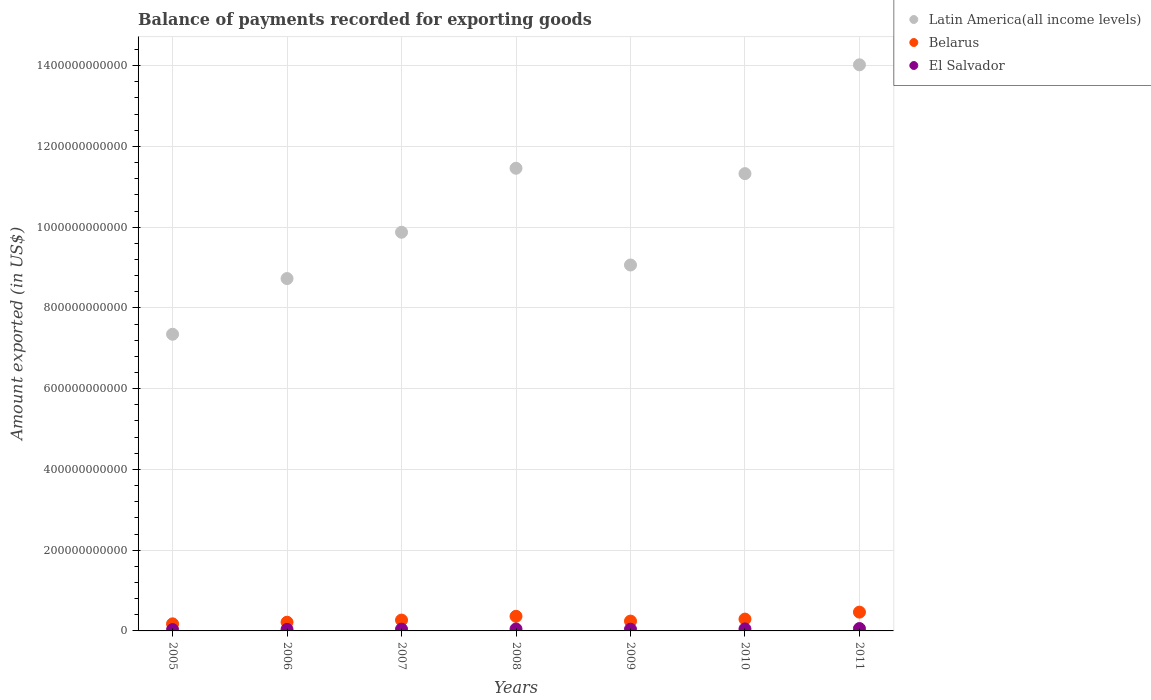How many different coloured dotlines are there?
Provide a succinct answer. 3. Is the number of dotlines equal to the number of legend labels?
Your response must be concise. Yes. What is the amount exported in Latin America(all income levels) in 2008?
Ensure brevity in your answer.  1.15e+12. Across all years, what is the maximum amount exported in El Salvador?
Your response must be concise. 5.88e+09. Across all years, what is the minimum amount exported in Latin America(all income levels)?
Keep it short and to the point. 7.35e+11. In which year was the amount exported in Belarus maximum?
Your answer should be compact. 2011. In which year was the amount exported in Belarus minimum?
Your response must be concise. 2005. What is the total amount exported in Belarus in the graph?
Provide a succinct answer. 2.02e+11. What is the difference between the amount exported in Latin America(all income levels) in 2009 and that in 2010?
Provide a succinct answer. -2.26e+11. What is the difference between the amount exported in Latin America(all income levels) in 2005 and the amount exported in El Salvador in 2008?
Provide a succinct answer. 7.30e+11. What is the average amount exported in Latin America(all income levels) per year?
Provide a short and direct response. 1.03e+12. In the year 2006, what is the difference between the amount exported in Belarus and amount exported in Latin America(all income levels)?
Your answer should be very brief. -8.51e+11. What is the ratio of the amount exported in El Salvador in 2007 to that in 2011?
Ensure brevity in your answer.  0.74. What is the difference between the highest and the second highest amount exported in Belarus?
Offer a terse response. 1.03e+1. What is the difference between the highest and the lowest amount exported in El Salvador?
Offer a terse response. 2.54e+09. In how many years, is the amount exported in Belarus greater than the average amount exported in Belarus taken over all years?
Ensure brevity in your answer.  3. Is the sum of the amount exported in Latin America(all income levels) in 2008 and 2009 greater than the maximum amount exported in El Salvador across all years?
Your response must be concise. Yes. Does the amount exported in Belarus monotonically increase over the years?
Offer a very short reply. No. What is the difference between two consecutive major ticks on the Y-axis?
Your answer should be compact. 2.00e+11. Are the values on the major ticks of Y-axis written in scientific E-notation?
Your answer should be very brief. No. Does the graph contain any zero values?
Offer a terse response. No. Does the graph contain grids?
Offer a very short reply. Yes. How many legend labels are there?
Ensure brevity in your answer.  3. What is the title of the graph?
Your answer should be compact. Balance of payments recorded for exporting goods. What is the label or title of the X-axis?
Offer a terse response. Years. What is the label or title of the Y-axis?
Provide a succinct answer. Amount exported (in US$). What is the Amount exported (in US$) in Latin America(all income levels) in 2005?
Offer a very short reply. 7.35e+11. What is the Amount exported (in US$) of Belarus in 2005?
Offer a very short reply. 1.75e+1. What is the Amount exported (in US$) in El Salvador in 2005?
Provide a succinct answer. 3.34e+09. What is the Amount exported (in US$) of Latin America(all income levels) in 2006?
Offer a terse response. 8.73e+11. What is the Amount exported (in US$) of Belarus in 2006?
Your answer should be very brief. 2.16e+1. What is the Amount exported (in US$) in El Salvador in 2006?
Keep it short and to the point. 3.77e+09. What is the Amount exported (in US$) in Latin America(all income levels) in 2007?
Make the answer very short. 9.87e+11. What is the Amount exported (in US$) in Belarus in 2007?
Your answer should be compact. 2.69e+1. What is the Amount exported (in US$) in El Salvador in 2007?
Your answer should be compact. 4.35e+09. What is the Amount exported (in US$) in Latin America(all income levels) in 2008?
Keep it short and to the point. 1.15e+12. What is the Amount exported (in US$) in Belarus in 2008?
Your response must be concise. 3.62e+1. What is the Amount exported (in US$) of El Salvador in 2008?
Your answer should be compact. 4.81e+09. What is the Amount exported (in US$) of Latin America(all income levels) in 2009?
Keep it short and to the point. 9.06e+11. What is the Amount exported (in US$) of Belarus in 2009?
Keep it short and to the point. 2.43e+1. What is the Amount exported (in US$) in El Salvador in 2009?
Provide a succinct answer. 4.22e+09. What is the Amount exported (in US$) of Latin America(all income levels) in 2010?
Your answer should be very brief. 1.13e+12. What is the Amount exported (in US$) of Belarus in 2010?
Your answer should be compact. 2.93e+1. What is the Amount exported (in US$) in El Salvador in 2010?
Your response must be concise. 4.97e+09. What is the Amount exported (in US$) in Latin America(all income levels) in 2011?
Provide a succinct answer. 1.40e+12. What is the Amount exported (in US$) in Belarus in 2011?
Ensure brevity in your answer.  4.65e+1. What is the Amount exported (in US$) of El Salvador in 2011?
Your response must be concise. 5.88e+09. Across all years, what is the maximum Amount exported (in US$) of Latin America(all income levels)?
Your response must be concise. 1.40e+12. Across all years, what is the maximum Amount exported (in US$) of Belarus?
Give a very brief answer. 4.65e+1. Across all years, what is the maximum Amount exported (in US$) in El Salvador?
Your response must be concise. 5.88e+09. Across all years, what is the minimum Amount exported (in US$) in Latin America(all income levels)?
Ensure brevity in your answer.  7.35e+11. Across all years, what is the minimum Amount exported (in US$) in Belarus?
Provide a short and direct response. 1.75e+1. Across all years, what is the minimum Amount exported (in US$) of El Salvador?
Offer a very short reply. 3.34e+09. What is the total Amount exported (in US$) of Latin America(all income levels) in the graph?
Your answer should be compact. 7.18e+12. What is the total Amount exported (in US$) of Belarus in the graph?
Your answer should be very brief. 2.02e+11. What is the total Amount exported (in US$) of El Salvador in the graph?
Offer a terse response. 3.13e+1. What is the difference between the Amount exported (in US$) of Latin America(all income levels) in 2005 and that in 2006?
Your answer should be very brief. -1.38e+11. What is the difference between the Amount exported (in US$) in Belarus in 2005 and that in 2006?
Provide a succinct answer. -4.03e+09. What is the difference between the Amount exported (in US$) of El Salvador in 2005 and that in 2006?
Offer a very short reply. -4.29e+08. What is the difference between the Amount exported (in US$) in Latin America(all income levels) in 2005 and that in 2007?
Ensure brevity in your answer.  -2.53e+11. What is the difference between the Amount exported (in US$) in Belarus in 2005 and that in 2007?
Offer a very short reply. -9.32e+09. What is the difference between the Amount exported (in US$) in El Salvador in 2005 and that in 2007?
Your answer should be very brief. -1.01e+09. What is the difference between the Amount exported (in US$) of Latin America(all income levels) in 2005 and that in 2008?
Give a very brief answer. -4.11e+11. What is the difference between the Amount exported (in US$) in Belarus in 2005 and that in 2008?
Give a very brief answer. -1.87e+1. What is the difference between the Amount exported (in US$) in El Salvador in 2005 and that in 2008?
Offer a terse response. -1.47e+09. What is the difference between the Amount exported (in US$) in Latin America(all income levels) in 2005 and that in 2009?
Keep it short and to the point. -1.72e+11. What is the difference between the Amount exported (in US$) in Belarus in 2005 and that in 2009?
Your answer should be very brief. -6.77e+09. What is the difference between the Amount exported (in US$) in El Salvador in 2005 and that in 2009?
Offer a terse response. -8.74e+08. What is the difference between the Amount exported (in US$) in Latin America(all income levels) in 2005 and that in 2010?
Your answer should be very brief. -3.98e+11. What is the difference between the Amount exported (in US$) of Belarus in 2005 and that in 2010?
Ensure brevity in your answer.  -1.18e+1. What is the difference between the Amount exported (in US$) of El Salvador in 2005 and that in 2010?
Your response must be concise. -1.63e+09. What is the difference between the Amount exported (in US$) of Latin America(all income levels) in 2005 and that in 2011?
Provide a short and direct response. -6.67e+11. What is the difference between the Amount exported (in US$) of Belarus in 2005 and that in 2011?
Make the answer very short. -2.90e+1. What is the difference between the Amount exported (in US$) of El Salvador in 2005 and that in 2011?
Your response must be concise. -2.54e+09. What is the difference between the Amount exported (in US$) in Latin America(all income levels) in 2006 and that in 2007?
Offer a very short reply. -1.15e+11. What is the difference between the Amount exported (in US$) in Belarus in 2006 and that in 2007?
Provide a short and direct response. -5.28e+09. What is the difference between the Amount exported (in US$) of El Salvador in 2006 and that in 2007?
Provide a succinct answer. -5.79e+08. What is the difference between the Amount exported (in US$) in Latin America(all income levels) in 2006 and that in 2008?
Provide a short and direct response. -2.73e+11. What is the difference between the Amount exported (in US$) in Belarus in 2006 and that in 2008?
Offer a very short reply. -1.46e+1. What is the difference between the Amount exported (in US$) of El Salvador in 2006 and that in 2008?
Keep it short and to the point. -1.04e+09. What is the difference between the Amount exported (in US$) in Latin America(all income levels) in 2006 and that in 2009?
Your answer should be very brief. -3.36e+1. What is the difference between the Amount exported (in US$) of Belarus in 2006 and that in 2009?
Offer a terse response. -2.74e+09. What is the difference between the Amount exported (in US$) of El Salvador in 2006 and that in 2009?
Your answer should be very brief. -4.45e+08. What is the difference between the Amount exported (in US$) of Latin America(all income levels) in 2006 and that in 2010?
Give a very brief answer. -2.60e+11. What is the difference between the Amount exported (in US$) in Belarus in 2006 and that in 2010?
Offer a very short reply. -7.73e+09. What is the difference between the Amount exported (in US$) of El Salvador in 2006 and that in 2010?
Give a very brief answer. -1.20e+09. What is the difference between the Amount exported (in US$) in Latin America(all income levels) in 2006 and that in 2011?
Give a very brief answer. -5.29e+11. What is the difference between the Amount exported (in US$) of Belarus in 2006 and that in 2011?
Ensure brevity in your answer.  -2.50e+1. What is the difference between the Amount exported (in US$) in El Salvador in 2006 and that in 2011?
Your response must be concise. -2.11e+09. What is the difference between the Amount exported (in US$) of Latin America(all income levels) in 2007 and that in 2008?
Provide a succinct answer. -1.58e+11. What is the difference between the Amount exported (in US$) of Belarus in 2007 and that in 2008?
Give a very brief answer. -9.37e+09. What is the difference between the Amount exported (in US$) of El Salvador in 2007 and that in 2008?
Ensure brevity in your answer.  -4.60e+08. What is the difference between the Amount exported (in US$) in Latin America(all income levels) in 2007 and that in 2009?
Ensure brevity in your answer.  8.11e+1. What is the difference between the Amount exported (in US$) in Belarus in 2007 and that in 2009?
Provide a succinct answer. 2.54e+09. What is the difference between the Amount exported (in US$) of El Salvador in 2007 and that in 2009?
Provide a succinct answer. 1.34e+08. What is the difference between the Amount exported (in US$) in Latin America(all income levels) in 2007 and that in 2010?
Provide a short and direct response. -1.45e+11. What is the difference between the Amount exported (in US$) of Belarus in 2007 and that in 2010?
Your response must be concise. -2.45e+09. What is the difference between the Amount exported (in US$) in El Salvador in 2007 and that in 2010?
Give a very brief answer. -6.22e+08. What is the difference between the Amount exported (in US$) of Latin America(all income levels) in 2007 and that in 2011?
Give a very brief answer. -4.15e+11. What is the difference between the Amount exported (in US$) of Belarus in 2007 and that in 2011?
Offer a very short reply. -1.97e+1. What is the difference between the Amount exported (in US$) in El Salvador in 2007 and that in 2011?
Provide a succinct answer. -1.53e+09. What is the difference between the Amount exported (in US$) in Latin America(all income levels) in 2008 and that in 2009?
Give a very brief answer. 2.40e+11. What is the difference between the Amount exported (in US$) in Belarus in 2008 and that in 2009?
Offer a terse response. 1.19e+1. What is the difference between the Amount exported (in US$) in El Salvador in 2008 and that in 2009?
Ensure brevity in your answer.  5.94e+08. What is the difference between the Amount exported (in US$) of Latin America(all income levels) in 2008 and that in 2010?
Your answer should be compact. 1.33e+1. What is the difference between the Amount exported (in US$) of Belarus in 2008 and that in 2010?
Offer a very short reply. 6.92e+09. What is the difference between the Amount exported (in US$) of El Salvador in 2008 and that in 2010?
Provide a short and direct response. -1.61e+08. What is the difference between the Amount exported (in US$) in Latin America(all income levels) in 2008 and that in 2011?
Offer a very short reply. -2.56e+11. What is the difference between the Amount exported (in US$) in Belarus in 2008 and that in 2011?
Provide a succinct answer. -1.03e+1. What is the difference between the Amount exported (in US$) in El Salvador in 2008 and that in 2011?
Make the answer very short. -1.07e+09. What is the difference between the Amount exported (in US$) of Latin America(all income levels) in 2009 and that in 2010?
Make the answer very short. -2.26e+11. What is the difference between the Amount exported (in US$) in Belarus in 2009 and that in 2010?
Provide a succinct answer. -4.99e+09. What is the difference between the Amount exported (in US$) in El Salvador in 2009 and that in 2010?
Give a very brief answer. -7.55e+08. What is the difference between the Amount exported (in US$) in Latin America(all income levels) in 2009 and that in 2011?
Your response must be concise. -4.96e+11. What is the difference between the Amount exported (in US$) in Belarus in 2009 and that in 2011?
Your answer should be very brief. -2.22e+1. What is the difference between the Amount exported (in US$) of El Salvador in 2009 and that in 2011?
Ensure brevity in your answer.  -1.66e+09. What is the difference between the Amount exported (in US$) of Latin America(all income levels) in 2010 and that in 2011?
Give a very brief answer. -2.70e+11. What is the difference between the Amount exported (in US$) of Belarus in 2010 and that in 2011?
Your response must be concise. -1.72e+1. What is the difference between the Amount exported (in US$) in El Salvador in 2010 and that in 2011?
Give a very brief answer. -9.07e+08. What is the difference between the Amount exported (in US$) in Latin America(all income levels) in 2005 and the Amount exported (in US$) in Belarus in 2006?
Give a very brief answer. 7.13e+11. What is the difference between the Amount exported (in US$) of Latin America(all income levels) in 2005 and the Amount exported (in US$) of El Salvador in 2006?
Your answer should be very brief. 7.31e+11. What is the difference between the Amount exported (in US$) of Belarus in 2005 and the Amount exported (in US$) of El Salvador in 2006?
Your answer should be very brief. 1.38e+1. What is the difference between the Amount exported (in US$) in Latin America(all income levels) in 2005 and the Amount exported (in US$) in Belarus in 2007?
Offer a terse response. 7.08e+11. What is the difference between the Amount exported (in US$) in Latin America(all income levels) in 2005 and the Amount exported (in US$) in El Salvador in 2007?
Give a very brief answer. 7.30e+11. What is the difference between the Amount exported (in US$) in Belarus in 2005 and the Amount exported (in US$) in El Salvador in 2007?
Your answer should be compact. 1.32e+1. What is the difference between the Amount exported (in US$) of Latin America(all income levels) in 2005 and the Amount exported (in US$) of Belarus in 2008?
Offer a terse response. 6.99e+11. What is the difference between the Amount exported (in US$) in Latin America(all income levels) in 2005 and the Amount exported (in US$) in El Salvador in 2008?
Make the answer very short. 7.30e+11. What is the difference between the Amount exported (in US$) in Belarus in 2005 and the Amount exported (in US$) in El Salvador in 2008?
Provide a short and direct response. 1.27e+1. What is the difference between the Amount exported (in US$) of Latin America(all income levels) in 2005 and the Amount exported (in US$) of Belarus in 2009?
Provide a short and direct response. 7.11e+11. What is the difference between the Amount exported (in US$) of Latin America(all income levels) in 2005 and the Amount exported (in US$) of El Salvador in 2009?
Provide a succinct answer. 7.31e+11. What is the difference between the Amount exported (in US$) of Belarus in 2005 and the Amount exported (in US$) of El Salvador in 2009?
Provide a succinct answer. 1.33e+1. What is the difference between the Amount exported (in US$) of Latin America(all income levels) in 2005 and the Amount exported (in US$) of Belarus in 2010?
Offer a terse response. 7.06e+11. What is the difference between the Amount exported (in US$) in Latin America(all income levels) in 2005 and the Amount exported (in US$) in El Salvador in 2010?
Your response must be concise. 7.30e+11. What is the difference between the Amount exported (in US$) in Belarus in 2005 and the Amount exported (in US$) in El Salvador in 2010?
Ensure brevity in your answer.  1.26e+1. What is the difference between the Amount exported (in US$) of Latin America(all income levels) in 2005 and the Amount exported (in US$) of Belarus in 2011?
Your response must be concise. 6.88e+11. What is the difference between the Amount exported (in US$) of Latin America(all income levels) in 2005 and the Amount exported (in US$) of El Salvador in 2011?
Your answer should be compact. 7.29e+11. What is the difference between the Amount exported (in US$) in Belarus in 2005 and the Amount exported (in US$) in El Salvador in 2011?
Provide a succinct answer. 1.17e+1. What is the difference between the Amount exported (in US$) in Latin America(all income levels) in 2006 and the Amount exported (in US$) in Belarus in 2007?
Your response must be concise. 8.46e+11. What is the difference between the Amount exported (in US$) of Latin America(all income levels) in 2006 and the Amount exported (in US$) of El Salvador in 2007?
Make the answer very short. 8.68e+11. What is the difference between the Amount exported (in US$) in Belarus in 2006 and the Amount exported (in US$) in El Salvador in 2007?
Your answer should be compact. 1.72e+1. What is the difference between the Amount exported (in US$) in Latin America(all income levels) in 2006 and the Amount exported (in US$) in Belarus in 2008?
Your answer should be compact. 8.37e+11. What is the difference between the Amount exported (in US$) of Latin America(all income levels) in 2006 and the Amount exported (in US$) of El Salvador in 2008?
Give a very brief answer. 8.68e+11. What is the difference between the Amount exported (in US$) in Belarus in 2006 and the Amount exported (in US$) in El Salvador in 2008?
Give a very brief answer. 1.68e+1. What is the difference between the Amount exported (in US$) in Latin America(all income levels) in 2006 and the Amount exported (in US$) in Belarus in 2009?
Offer a very short reply. 8.48e+11. What is the difference between the Amount exported (in US$) in Latin America(all income levels) in 2006 and the Amount exported (in US$) in El Salvador in 2009?
Your answer should be very brief. 8.69e+11. What is the difference between the Amount exported (in US$) of Belarus in 2006 and the Amount exported (in US$) of El Salvador in 2009?
Offer a very short reply. 1.74e+1. What is the difference between the Amount exported (in US$) of Latin America(all income levels) in 2006 and the Amount exported (in US$) of Belarus in 2010?
Make the answer very short. 8.43e+11. What is the difference between the Amount exported (in US$) of Latin America(all income levels) in 2006 and the Amount exported (in US$) of El Salvador in 2010?
Offer a terse response. 8.68e+11. What is the difference between the Amount exported (in US$) in Belarus in 2006 and the Amount exported (in US$) in El Salvador in 2010?
Keep it short and to the point. 1.66e+1. What is the difference between the Amount exported (in US$) of Latin America(all income levels) in 2006 and the Amount exported (in US$) of Belarus in 2011?
Ensure brevity in your answer.  8.26e+11. What is the difference between the Amount exported (in US$) of Latin America(all income levels) in 2006 and the Amount exported (in US$) of El Salvador in 2011?
Provide a short and direct response. 8.67e+11. What is the difference between the Amount exported (in US$) of Belarus in 2006 and the Amount exported (in US$) of El Salvador in 2011?
Make the answer very short. 1.57e+1. What is the difference between the Amount exported (in US$) in Latin America(all income levels) in 2007 and the Amount exported (in US$) in Belarus in 2008?
Offer a terse response. 9.51e+11. What is the difference between the Amount exported (in US$) in Latin America(all income levels) in 2007 and the Amount exported (in US$) in El Salvador in 2008?
Offer a terse response. 9.83e+11. What is the difference between the Amount exported (in US$) of Belarus in 2007 and the Amount exported (in US$) of El Salvador in 2008?
Give a very brief answer. 2.20e+1. What is the difference between the Amount exported (in US$) in Latin America(all income levels) in 2007 and the Amount exported (in US$) in Belarus in 2009?
Keep it short and to the point. 9.63e+11. What is the difference between the Amount exported (in US$) in Latin America(all income levels) in 2007 and the Amount exported (in US$) in El Salvador in 2009?
Your answer should be very brief. 9.83e+11. What is the difference between the Amount exported (in US$) in Belarus in 2007 and the Amount exported (in US$) in El Salvador in 2009?
Provide a short and direct response. 2.26e+1. What is the difference between the Amount exported (in US$) of Latin America(all income levels) in 2007 and the Amount exported (in US$) of Belarus in 2010?
Make the answer very short. 9.58e+11. What is the difference between the Amount exported (in US$) of Latin America(all income levels) in 2007 and the Amount exported (in US$) of El Salvador in 2010?
Give a very brief answer. 9.83e+11. What is the difference between the Amount exported (in US$) in Belarus in 2007 and the Amount exported (in US$) in El Salvador in 2010?
Make the answer very short. 2.19e+1. What is the difference between the Amount exported (in US$) of Latin America(all income levels) in 2007 and the Amount exported (in US$) of Belarus in 2011?
Provide a succinct answer. 9.41e+11. What is the difference between the Amount exported (in US$) in Latin America(all income levels) in 2007 and the Amount exported (in US$) in El Salvador in 2011?
Ensure brevity in your answer.  9.82e+11. What is the difference between the Amount exported (in US$) of Belarus in 2007 and the Amount exported (in US$) of El Salvador in 2011?
Your response must be concise. 2.10e+1. What is the difference between the Amount exported (in US$) of Latin America(all income levels) in 2008 and the Amount exported (in US$) of Belarus in 2009?
Your answer should be very brief. 1.12e+12. What is the difference between the Amount exported (in US$) of Latin America(all income levels) in 2008 and the Amount exported (in US$) of El Salvador in 2009?
Make the answer very short. 1.14e+12. What is the difference between the Amount exported (in US$) of Belarus in 2008 and the Amount exported (in US$) of El Salvador in 2009?
Ensure brevity in your answer.  3.20e+1. What is the difference between the Amount exported (in US$) in Latin America(all income levels) in 2008 and the Amount exported (in US$) in Belarus in 2010?
Provide a succinct answer. 1.12e+12. What is the difference between the Amount exported (in US$) in Latin America(all income levels) in 2008 and the Amount exported (in US$) in El Salvador in 2010?
Offer a terse response. 1.14e+12. What is the difference between the Amount exported (in US$) of Belarus in 2008 and the Amount exported (in US$) of El Salvador in 2010?
Make the answer very short. 3.12e+1. What is the difference between the Amount exported (in US$) of Latin America(all income levels) in 2008 and the Amount exported (in US$) of Belarus in 2011?
Offer a terse response. 1.10e+12. What is the difference between the Amount exported (in US$) of Latin America(all income levels) in 2008 and the Amount exported (in US$) of El Salvador in 2011?
Provide a succinct answer. 1.14e+12. What is the difference between the Amount exported (in US$) in Belarus in 2008 and the Amount exported (in US$) in El Salvador in 2011?
Your answer should be very brief. 3.03e+1. What is the difference between the Amount exported (in US$) in Latin America(all income levels) in 2009 and the Amount exported (in US$) in Belarus in 2010?
Your response must be concise. 8.77e+11. What is the difference between the Amount exported (in US$) in Latin America(all income levels) in 2009 and the Amount exported (in US$) in El Salvador in 2010?
Offer a very short reply. 9.01e+11. What is the difference between the Amount exported (in US$) in Belarus in 2009 and the Amount exported (in US$) in El Salvador in 2010?
Your answer should be very brief. 1.93e+1. What is the difference between the Amount exported (in US$) of Latin America(all income levels) in 2009 and the Amount exported (in US$) of Belarus in 2011?
Offer a terse response. 8.60e+11. What is the difference between the Amount exported (in US$) in Latin America(all income levels) in 2009 and the Amount exported (in US$) in El Salvador in 2011?
Your answer should be compact. 9.00e+11. What is the difference between the Amount exported (in US$) of Belarus in 2009 and the Amount exported (in US$) of El Salvador in 2011?
Provide a succinct answer. 1.84e+1. What is the difference between the Amount exported (in US$) of Latin America(all income levels) in 2010 and the Amount exported (in US$) of Belarus in 2011?
Offer a very short reply. 1.09e+12. What is the difference between the Amount exported (in US$) of Latin America(all income levels) in 2010 and the Amount exported (in US$) of El Salvador in 2011?
Your answer should be compact. 1.13e+12. What is the difference between the Amount exported (in US$) in Belarus in 2010 and the Amount exported (in US$) in El Salvador in 2011?
Give a very brief answer. 2.34e+1. What is the average Amount exported (in US$) in Latin America(all income levels) per year?
Provide a succinct answer. 1.03e+12. What is the average Amount exported (in US$) of Belarus per year?
Your answer should be compact. 2.89e+1. What is the average Amount exported (in US$) of El Salvador per year?
Offer a terse response. 4.48e+09. In the year 2005, what is the difference between the Amount exported (in US$) of Latin America(all income levels) and Amount exported (in US$) of Belarus?
Offer a very short reply. 7.17e+11. In the year 2005, what is the difference between the Amount exported (in US$) of Latin America(all income levels) and Amount exported (in US$) of El Salvador?
Give a very brief answer. 7.31e+11. In the year 2005, what is the difference between the Amount exported (in US$) of Belarus and Amount exported (in US$) of El Salvador?
Give a very brief answer. 1.42e+1. In the year 2006, what is the difference between the Amount exported (in US$) of Latin America(all income levels) and Amount exported (in US$) of Belarus?
Give a very brief answer. 8.51e+11. In the year 2006, what is the difference between the Amount exported (in US$) in Latin America(all income levels) and Amount exported (in US$) in El Salvador?
Your answer should be compact. 8.69e+11. In the year 2006, what is the difference between the Amount exported (in US$) in Belarus and Amount exported (in US$) in El Salvador?
Make the answer very short. 1.78e+1. In the year 2007, what is the difference between the Amount exported (in US$) in Latin America(all income levels) and Amount exported (in US$) in Belarus?
Your answer should be compact. 9.61e+11. In the year 2007, what is the difference between the Amount exported (in US$) in Latin America(all income levels) and Amount exported (in US$) in El Salvador?
Make the answer very short. 9.83e+11. In the year 2007, what is the difference between the Amount exported (in US$) of Belarus and Amount exported (in US$) of El Salvador?
Your response must be concise. 2.25e+1. In the year 2008, what is the difference between the Amount exported (in US$) in Latin America(all income levels) and Amount exported (in US$) in Belarus?
Offer a terse response. 1.11e+12. In the year 2008, what is the difference between the Amount exported (in US$) in Latin America(all income levels) and Amount exported (in US$) in El Salvador?
Offer a very short reply. 1.14e+12. In the year 2008, what is the difference between the Amount exported (in US$) of Belarus and Amount exported (in US$) of El Salvador?
Provide a short and direct response. 3.14e+1. In the year 2009, what is the difference between the Amount exported (in US$) in Latin America(all income levels) and Amount exported (in US$) in Belarus?
Give a very brief answer. 8.82e+11. In the year 2009, what is the difference between the Amount exported (in US$) in Latin America(all income levels) and Amount exported (in US$) in El Salvador?
Provide a short and direct response. 9.02e+11. In the year 2009, what is the difference between the Amount exported (in US$) in Belarus and Amount exported (in US$) in El Salvador?
Keep it short and to the point. 2.01e+1. In the year 2010, what is the difference between the Amount exported (in US$) in Latin America(all income levels) and Amount exported (in US$) in Belarus?
Keep it short and to the point. 1.10e+12. In the year 2010, what is the difference between the Amount exported (in US$) of Latin America(all income levels) and Amount exported (in US$) of El Salvador?
Ensure brevity in your answer.  1.13e+12. In the year 2010, what is the difference between the Amount exported (in US$) of Belarus and Amount exported (in US$) of El Salvador?
Your answer should be very brief. 2.43e+1. In the year 2011, what is the difference between the Amount exported (in US$) of Latin America(all income levels) and Amount exported (in US$) of Belarus?
Keep it short and to the point. 1.36e+12. In the year 2011, what is the difference between the Amount exported (in US$) of Latin America(all income levels) and Amount exported (in US$) of El Salvador?
Offer a very short reply. 1.40e+12. In the year 2011, what is the difference between the Amount exported (in US$) of Belarus and Amount exported (in US$) of El Salvador?
Your response must be concise. 4.07e+1. What is the ratio of the Amount exported (in US$) in Latin America(all income levels) in 2005 to that in 2006?
Give a very brief answer. 0.84. What is the ratio of the Amount exported (in US$) of Belarus in 2005 to that in 2006?
Make the answer very short. 0.81. What is the ratio of the Amount exported (in US$) in El Salvador in 2005 to that in 2006?
Make the answer very short. 0.89. What is the ratio of the Amount exported (in US$) of Latin America(all income levels) in 2005 to that in 2007?
Keep it short and to the point. 0.74. What is the ratio of the Amount exported (in US$) in Belarus in 2005 to that in 2007?
Make the answer very short. 0.65. What is the ratio of the Amount exported (in US$) in El Salvador in 2005 to that in 2007?
Offer a very short reply. 0.77. What is the ratio of the Amount exported (in US$) in Latin America(all income levels) in 2005 to that in 2008?
Give a very brief answer. 0.64. What is the ratio of the Amount exported (in US$) of Belarus in 2005 to that in 2008?
Provide a succinct answer. 0.48. What is the ratio of the Amount exported (in US$) in El Salvador in 2005 to that in 2008?
Your answer should be very brief. 0.69. What is the ratio of the Amount exported (in US$) in Latin America(all income levels) in 2005 to that in 2009?
Offer a terse response. 0.81. What is the ratio of the Amount exported (in US$) of Belarus in 2005 to that in 2009?
Provide a short and direct response. 0.72. What is the ratio of the Amount exported (in US$) in El Salvador in 2005 to that in 2009?
Give a very brief answer. 0.79. What is the ratio of the Amount exported (in US$) in Latin America(all income levels) in 2005 to that in 2010?
Provide a short and direct response. 0.65. What is the ratio of the Amount exported (in US$) of Belarus in 2005 to that in 2010?
Offer a very short reply. 0.6. What is the ratio of the Amount exported (in US$) in El Salvador in 2005 to that in 2010?
Provide a succinct answer. 0.67. What is the ratio of the Amount exported (in US$) in Latin America(all income levels) in 2005 to that in 2011?
Keep it short and to the point. 0.52. What is the ratio of the Amount exported (in US$) in Belarus in 2005 to that in 2011?
Ensure brevity in your answer.  0.38. What is the ratio of the Amount exported (in US$) of El Salvador in 2005 to that in 2011?
Your answer should be compact. 0.57. What is the ratio of the Amount exported (in US$) in Latin America(all income levels) in 2006 to that in 2007?
Provide a short and direct response. 0.88. What is the ratio of the Amount exported (in US$) in Belarus in 2006 to that in 2007?
Provide a succinct answer. 0.8. What is the ratio of the Amount exported (in US$) of El Salvador in 2006 to that in 2007?
Keep it short and to the point. 0.87. What is the ratio of the Amount exported (in US$) of Latin America(all income levels) in 2006 to that in 2008?
Keep it short and to the point. 0.76. What is the ratio of the Amount exported (in US$) of Belarus in 2006 to that in 2008?
Provide a short and direct response. 0.6. What is the ratio of the Amount exported (in US$) in El Salvador in 2006 to that in 2008?
Give a very brief answer. 0.78. What is the ratio of the Amount exported (in US$) of Latin America(all income levels) in 2006 to that in 2009?
Give a very brief answer. 0.96. What is the ratio of the Amount exported (in US$) in Belarus in 2006 to that in 2009?
Your answer should be compact. 0.89. What is the ratio of the Amount exported (in US$) in El Salvador in 2006 to that in 2009?
Your response must be concise. 0.89. What is the ratio of the Amount exported (in US$) in Latin America(all income levels) in 2006 to that in 2010?
Keep it short and to the point. 0.77. What is the ratio of the Amount exported (in US$) of Belarus in 2006 to that in 2010?
Keep it short and to the point. 0.74. What is the ratio of the Amount exported (in US$) in El Salvador in 2006 to that in 2010?
Offer a very short reply. 0.76. What is the ratio of the Amount exported (in US$) of Latin America(all income levels) in 2006 to that in 2011?
Your answer should be compact. 0.62. What is the ratio of the Amount exported (in US$) of Belarus in 2006 to that in 2011?
Give a very brief answer. 0.46. What is the ratio of the Amount exported (in US$) of El Salvador in 2006 to that in 2011?
Make the answer very short. 0.64. What is the ratio of the Amount exported (in US$) in Latin America(all income levels) in 2007 to that in 2008?
Make the answer very short. 0.86. What is the ratio of the Amount exported (in US$) of Belarus in 2007 to that in 2008?
Offer a very short reply. 0.74. What is the ratio of the Amount exported (in US$) of El Salvador in 2007 to that in 2008?
Offer a very short reply. 0.9. What is the ratio of the Amount exported (in US$) in Latin America(all income levels) in 2007 to that in 2009?
Your response must be concise. 1.09. What is the ratio of the Amount exported (in US$) in Belarus in 2007 to that in 2009?
Your answer should be compact. 1.1. What is the ratio of the Amount exported (in US$) in El Salvador in 2007 to that in 2009?
Your answer should be compact. 1.03. What is the ratio of the Amount exported (in US$) in Latin America(all income levels) in 2007 to that in 2010?
Your answer should be compact. 0.87. What is the ratio of the Amount exported (in US$) of Belarus in 2007 to that in 2010?
Your answer should be compact. 0.92. What is the ratio of the Amount exported (in US$) of El Salvador in 2007 to that in 2010?
Offer a very short reply. 0.87. What is the ratio of the Amount exported (in US$) of Latin America(all income levels) in 2007 to that in 2011?
Provide a succinct answer. 0.7. What is the ratio of the Amount exported (in US$) in Belarus in 2007 to that in 2011?
Make the answer very short. 0.58. What is the ratio of the Amount exported (in US$) in El Salvador in 2007 to that in 2011?
Ensure brevity in your answer.  0.74. What is the ratio of the Amount exported (in US$) in Latin America(all income levels) in 2008 to that in 2009?
Your response must be concise. 1.26. What is the ratio of the Amount exported (in US$) in Belarus in 2008 to that in 2009?
Offer a terse response. 1.49. What is the ratio of the Amount exported (in US$) in El Salvador in 2008 to that in 2009?
Ensure brevity in your answer.  1.14. What is the ratio of the Amount exported (in US$) of Latin America(all income levels) in 2008 to that in 2010?
Give a very brief answer. 1.01. What is the ratio of the Amount exported (in US$) in Belarus in 2008 to that in 2010?
Your answer should be compact. 1.24. What is the ratio of the Amount exported (in US$) in El Salvador in 2008 to that in 2010?
Provide a short and direct response. 0.97. What is the ratio of the Amount exported (in US$) in Latin America(all income levels) in 2008 to that in 2011?
Give a very brief answer. 0.82. What is the ratio of the Amount exported (in US$) in Belarus in 2008 to that in 2011?
Your answer should be very brief. 0.78. What is the ratio of the Amount exported (in US$) of El Salvador in 2008 to that in 2011?
Offer a terse response. 0.82. What is the ratio of the Amount exported (in US$) in Latin America(all income levels) in 2009 to that in 2010?
Offer a terse response. 0.8. What is the ratio of the Amount exported (in US$) in Belarus in 2009 to that in 2010?
Your response must be concise. 0.83. What is the ratio of the Amount exported (in US$) of El Salvador in 2009 to that in 2010?
Your answer should be very brief. 0.85. What is the ratio of the Amount exported (in US$) of Latin America(all income levels) in 2009 to that in 2011?
Provide a short and direct response. 0.65. What is the ratio of the Amount exported (in US$) of Belarus in 2009 to that in 2011?
Give a very brief answer. 0.52. What is the ratio of the Amount exported (in US$) of El Salvador in 2009 to that in 2011?
Provide a short and direct response. 0.72. What is the ratio of the Amount exported (in US$) in Latin America(all income levels) in 2010 to that in 2011?
Keep it short and to the point. 0.81. What is the ratio of the Amount exported (in US$) in Belarus in 2010 to that in 2011?
Offer a very short reply. 0.63. What is the ratio of the Amount exported (in US$) of El Salvador in 2010 to that in 2011?
Ensure brevity in your answer.  0.85. What is the difference between the highest and the second highest Amount exported (in US$) of Latin America(all income levels)?
Offer a very short reply. 2.56e+11. What is the difference between the highest and the second highest Amount exported (in US$) in Belarus?
Provide a succinct answer. 1.03e+1. What is the difference between the highest and the second highest Amount exported (in US$) in El Salvador?
Your answer should be very brief. 9.07e+08. What is the difference between the highest and the lowest Amount exported (in US$) of Latin America(all income levels)?
Provide a succinct answer. 6.67e+11. What is the difference between the highest and the lowest Amount exported (in US$) of Belarus?
Keep it short and to the point. 2.90e+1. What is the difference between the highest and the lowest Amount exported (in US$) in El Salvador?
Ensure brevity in your answer.  2.54e+09. 